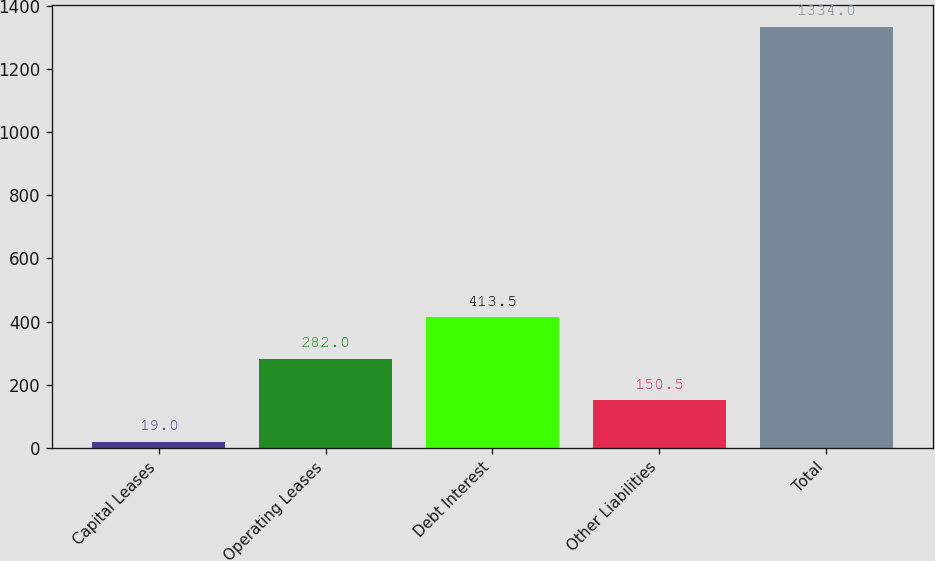<chart> <loc_0><loc_0><loc_500><loc_500><bar_chart><fcel>Capital Leases<fcel>Operating Leases<fcel>Debt Interest<fcel>Other Liabilities<fcel>Total<nl><fcel>19<fcel>282<fcel>413.5<fcel>150.5<fcel>1334<nl></chart> 